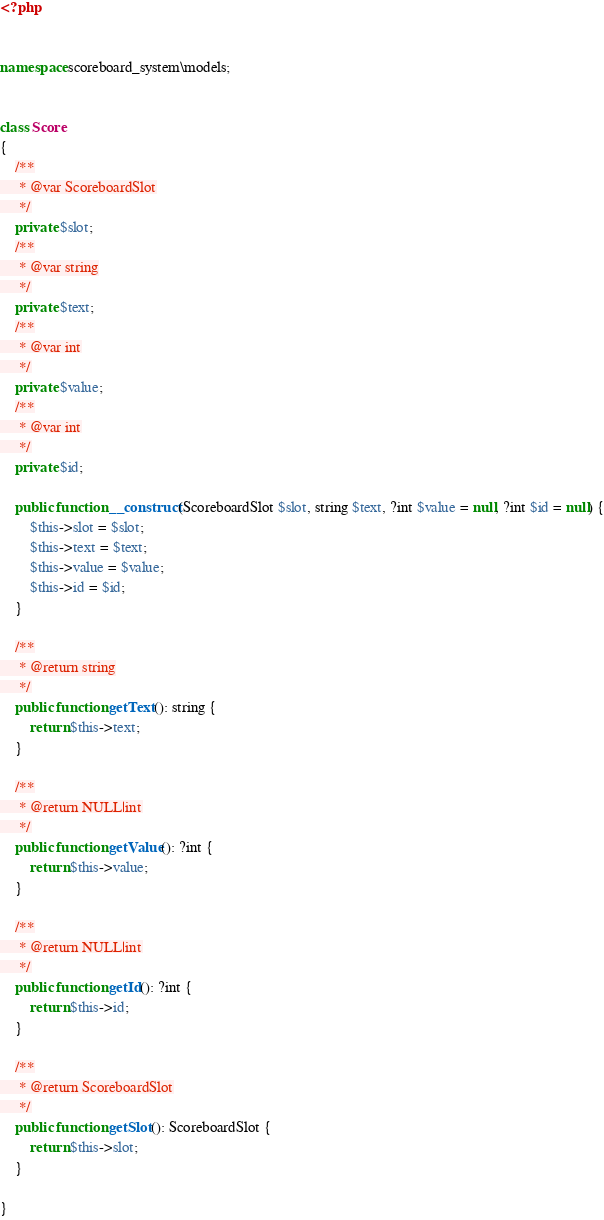Convert code to text. <code><loc_0><loc_0><loc_500><loc_500><_PHP_><?php


namespace scoreboard_system\models;


class Score
{
    /**
     * @var ScoreboardSlot
     */
    private $slot;
    /**
     * @var string
     */
    private $text;
    /**
     * @var int
     */
    private $value;
    /**
     * @var int
     */
    private $id;

    public function __construct(ScoreboardSlot $slot, string $text, ?int $value = null, ?int $id = null) {
        $this->slot = $slot;
        $this->text = $text;
        $this->value = $value;
        $this->id = $id;
    }

    /**
     * @return string
     */
    public function getText(): string {
        return $this->text;
    }

    /**
     * @return NULL|int
     */
    public function getValue(): ?int {
        return $this->value;
    }

    /**
     * @return NULL|int
     */
    public function getId(): ?int {
        return $this->id;
    }

    /**
     * @return ScoreboardSlot
     */
    public function getSlot(): ScoreboardSlot {
        return $this->slot;
    }

}</code> 